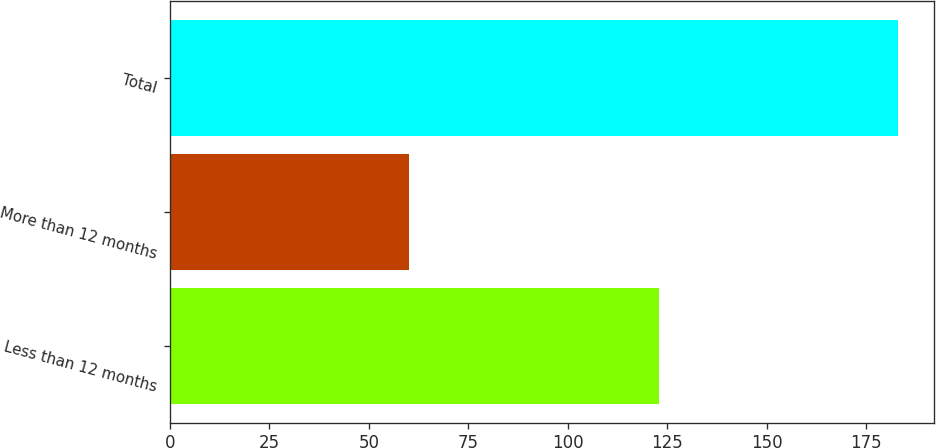Convert chart. <chart><loc_0><loc_0><loc_500><loc_500><bar_chart><fcel>Less than 12 months<fcel>More than 12 months<fcel>Total<nl><fcel>123<fcel>60<fcel>183<nl></chart> 